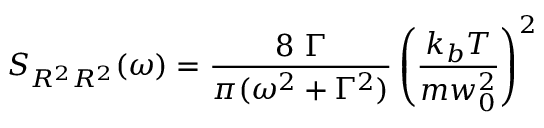<formula> <loc_0><loc_0><loc_500><loc_500>S _ { R ^ { 2 } R ^ { 2 } } ( \omega ) = \frac { 8 \ \Gamma } { \pi ( \omega ^ { 2 } + \Gamma ^ { 2 } ) } \left ( \frac { k _ { b } T } { m w _ { 0 } ^ { 2 } } \right ) ^ { 2 }</formula> 